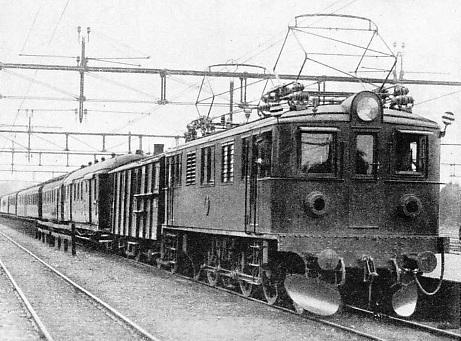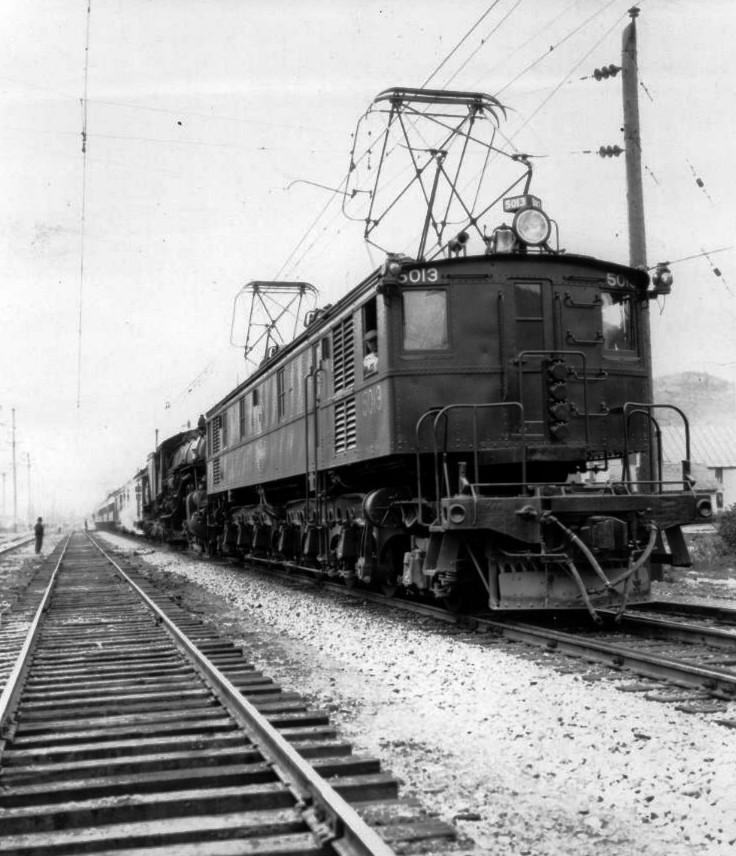The first image is the image on the left, the second image is the image on the right. Assess this claim about the two images: "Multiple people are standing in the lefthand vintage train image, and the right image shows a leftward-headed train.". Correct or not? Answer yes or no. No. 